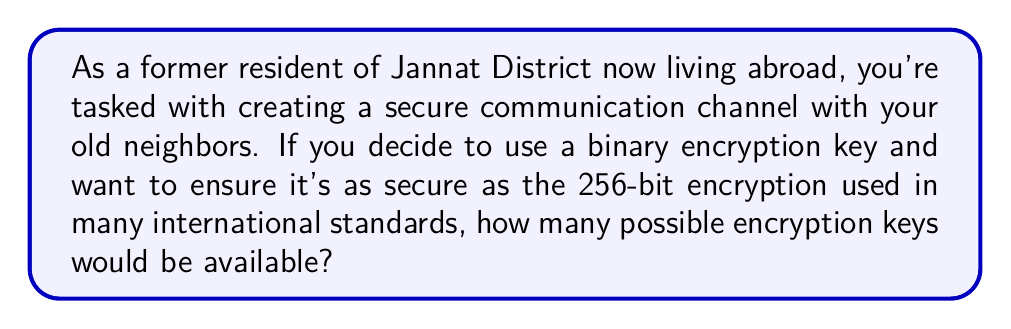Can you solve this math problem? Let's approach this step-by-step:

1) First, we need to understand what a binary encryption key is. In binary, each digit (or bit) can be either 0 or 1.

2) We're told that we want a key as secure as a 256-bit encryption. This means our key length is 256 bits.

3) For each bit in the key, we have 2 choices (0 or 1).

4) To calculate the total number of possible keys, we need to consider all possible combinations of these choices for all 256 bits.

5) This is a perfect scenario for using exponentiation. The number of possible keys is:

   $$ 2^{256} $$

6) This is because for each of the 256 positions, we have 2 choices, and we multiply these choices together 256 times.

7) Calculating this number:

   $$ 2^{256} = 115,792,089,237,316,195,423,570,985,008,687,907,853,269,984,665,640,564,039,457,584,007,913,129,639,936 $$

This is an enormous number, which is why 256-bit encryption is considered very secure.
Answer: $2^{256}$ 